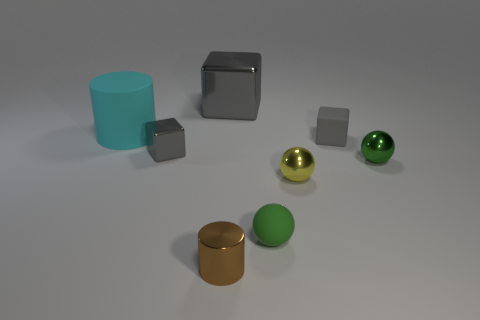The cyan rubber object has what shape?
Provide a succinct answer. Cylinder. Is the material of the large cyan cylinder the same as the yellow object?
Offer a terse response. No. Is the number of cyan cylinders behind the large shiny thing the same as the number of tiny shiny things to the left of the tiny green matte object?
Provide a succinct answer. No. There is a rubber object that is behind the tiny gray block behind the small metallic block; are there any small rubber spheres to the right of it?
Provide a short and direct response. Yes. Does the green metallic sphere have the same size as the cyan matte thing?
Your answer should be compact. No. The tiny shiny object behind the green thing to the right of the small rubber cube right of the big cyan rubber object is what color?
Ensure brevity in your answer.  Gray. What number of tiny objects have the same color as the tiny rubber ball?
Offer a very short reply. 1. Is there a large cyan object that has the same shape as the tiny gray matte object?
Your answer should be very brief. No. Is the shape of the tiny green shiny thing the same as the tiny brown object?
Offer a very short reply. No. There is a object that is in front of the rubber object in front of the green shiny sphere; what color is it?
Your answer should be compact. Brown. 